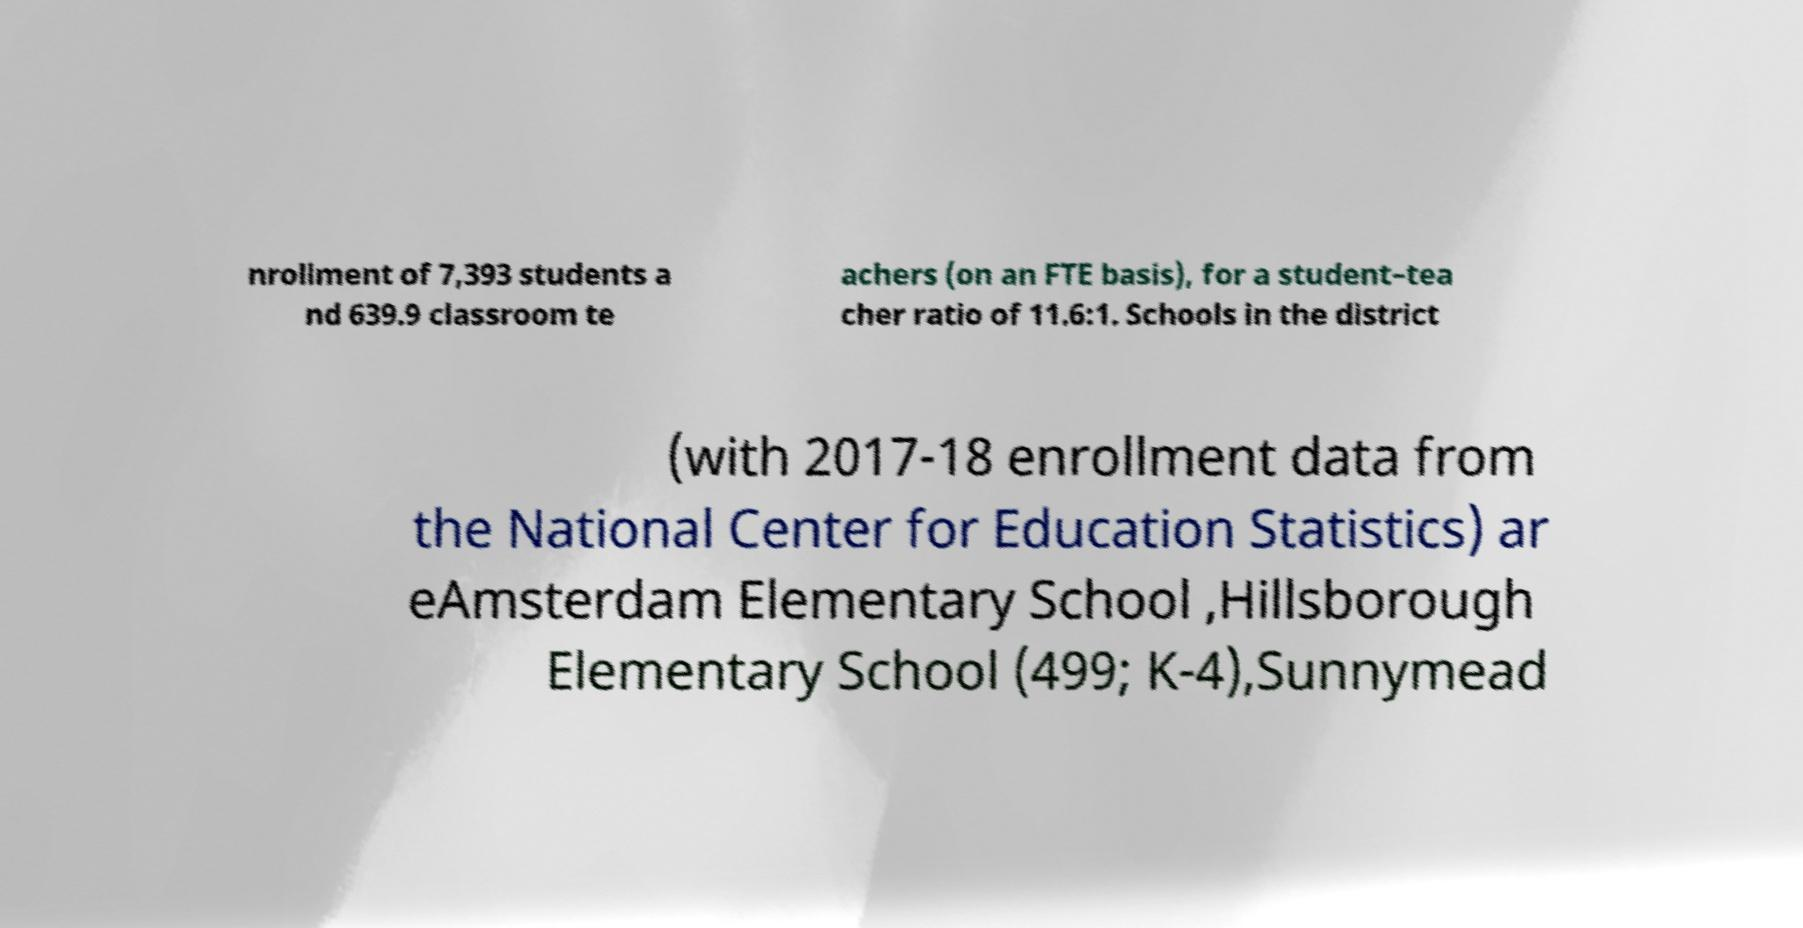Could you assist in decoding the text presented in this image and type it out clearly? nrollment of 7,393 students a nd 639.9 classroom te achers (on an FTE basis), for a student–tea cher ratio of 11.6:1. Schools in the district (with 2017-18 enrollment data from the National Center for Education Statistics) ar eAmsterdam Elementary School ,Hillsborough Elementary School (499; K-4),Sunnymead 